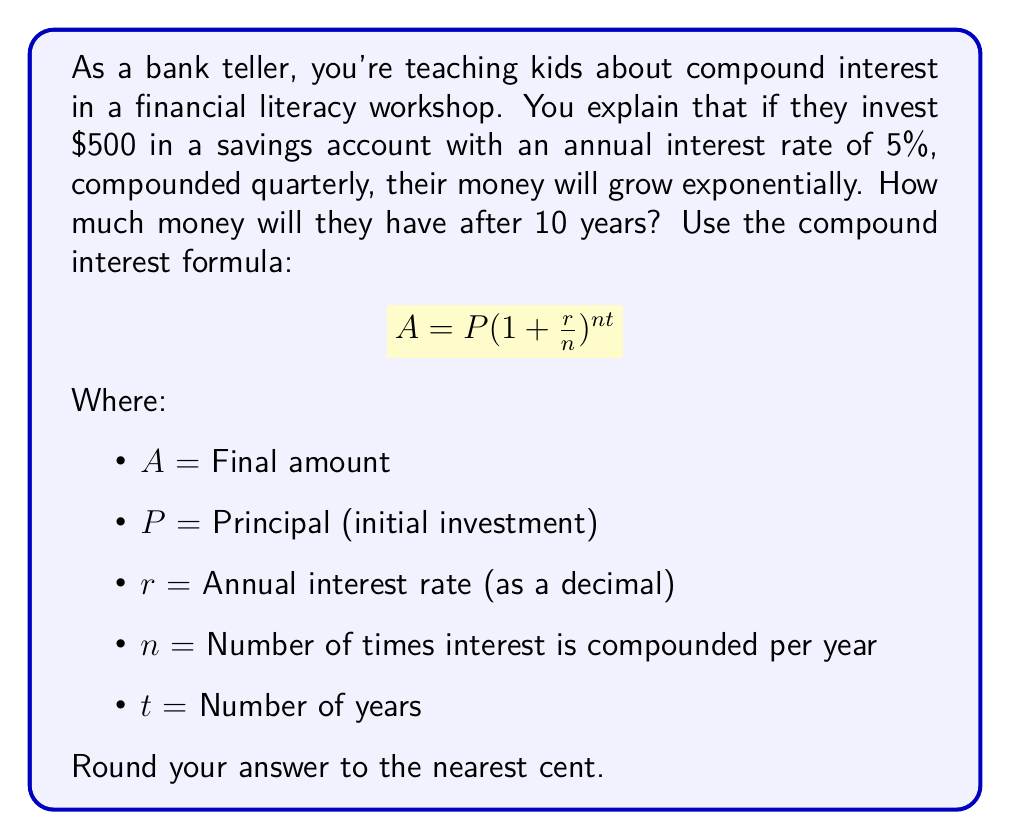What is the answer to this math problem? Let's solve this problem step by step:

1. Identify the given values:
   P = $500 (initial investment)
   r = 0.05 (5% annual interest rate as a decimal)
   n = 4 (compounded quarterly, so 4 times per year)
   t = 10 years

2. Plug these values into the compound interest formula:

   $$A = 500(1 + \frac{0.05}{4})^{4 * 10}$$

3. Simplify the expression inside the parentheses:

   $$A = 500(1 + 0.0125)^{40}$$

4. Calculate the value inside the parentheses:

   $$A = 500(1.0125)^{40}$$

5. Use a calculator to compute $(1.0125)^{40}$:

   $(1.0125)^{40} \approx 1.64700950$

6. Multiply this result by the initial investment:

   $$A = 500 * 1.64700950 = 823.50475$$

7. Round to the nearest cent:

   $A \approx $823.50$
Answer: $823.50 